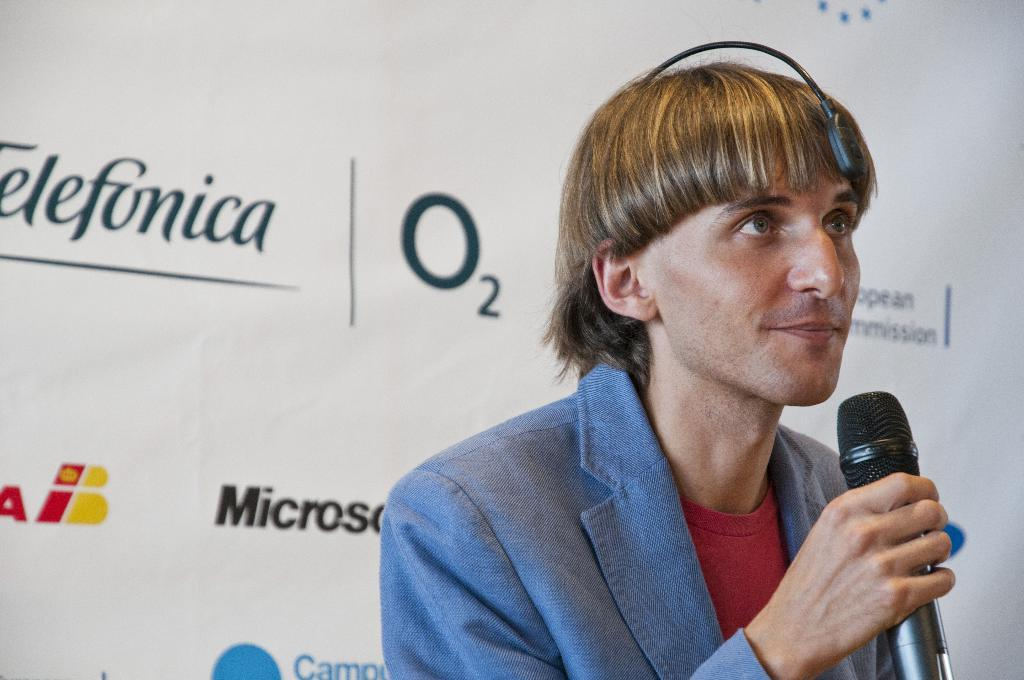What is the main subject in the foreground of the image? There is a person in the foreground of the image. What is the person holding in the image? The person is holding a microphone. What can be seen in the background of the image? There are texts written on a white surface in the background of the image. What type of pipe can be seen in the image? There is no pipe present in the image. What offer is the person making with the microphone in the image? The image does not provide information about any offer being made; it simply shows a person holding a microphone. 